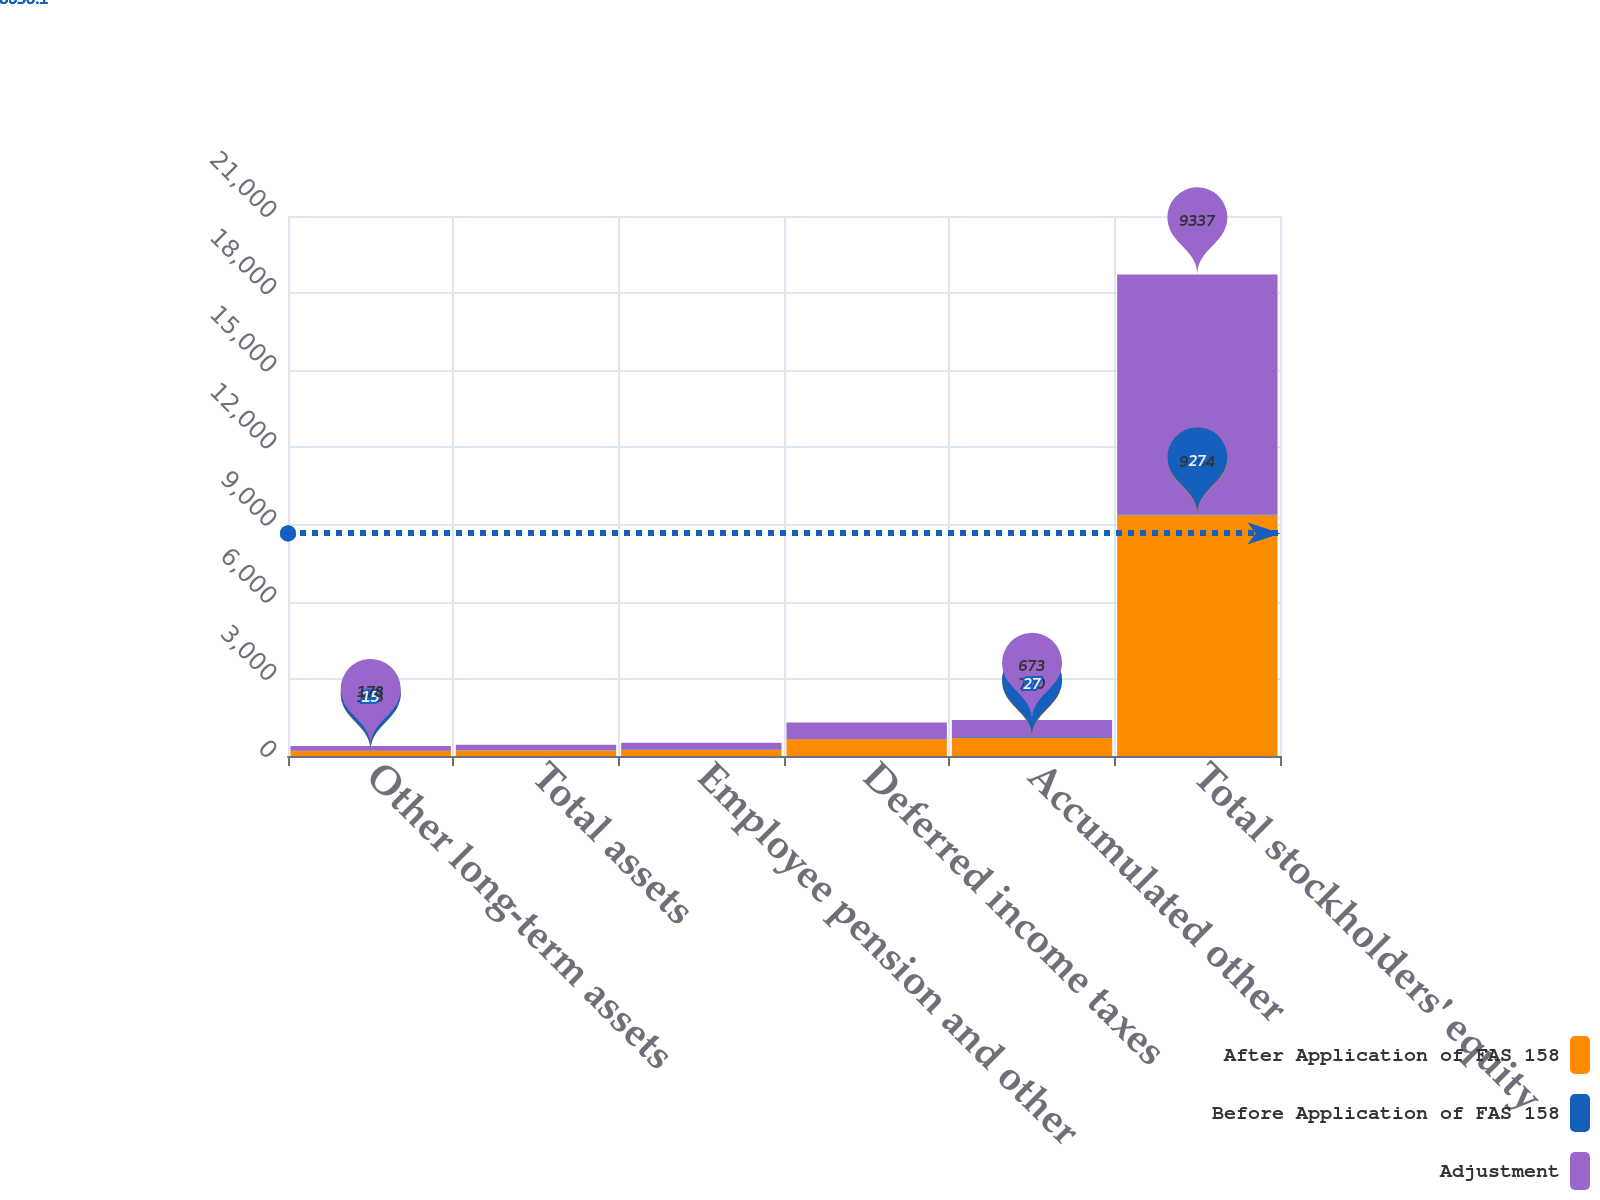<chart> <loc_0><loc_0><loc_500><loc_500><stacked_bar_chart><ecel><fcel>Other long-term assets<fcel>Total assets<fcel>Employee pension and other<fcel>Deferred income taxes<fcel>Accumulated other<fcel>Total stockholders' equity<nl><fcel>After Application of FAS 158<fcel>193<fcel>211<fcel>229<fcel>649<fcel>700<fcel>9364<nl><fcel>Before Application of FAS 158<fcel>15<fcel>15<fcel>27<fcel>14<fcel>27<fcel>27<nl><fcel>Adjustment<fcel>178<fcel>211<fcel>256<fcel>635<fcel>673<fcel>9337<nl></chart> 